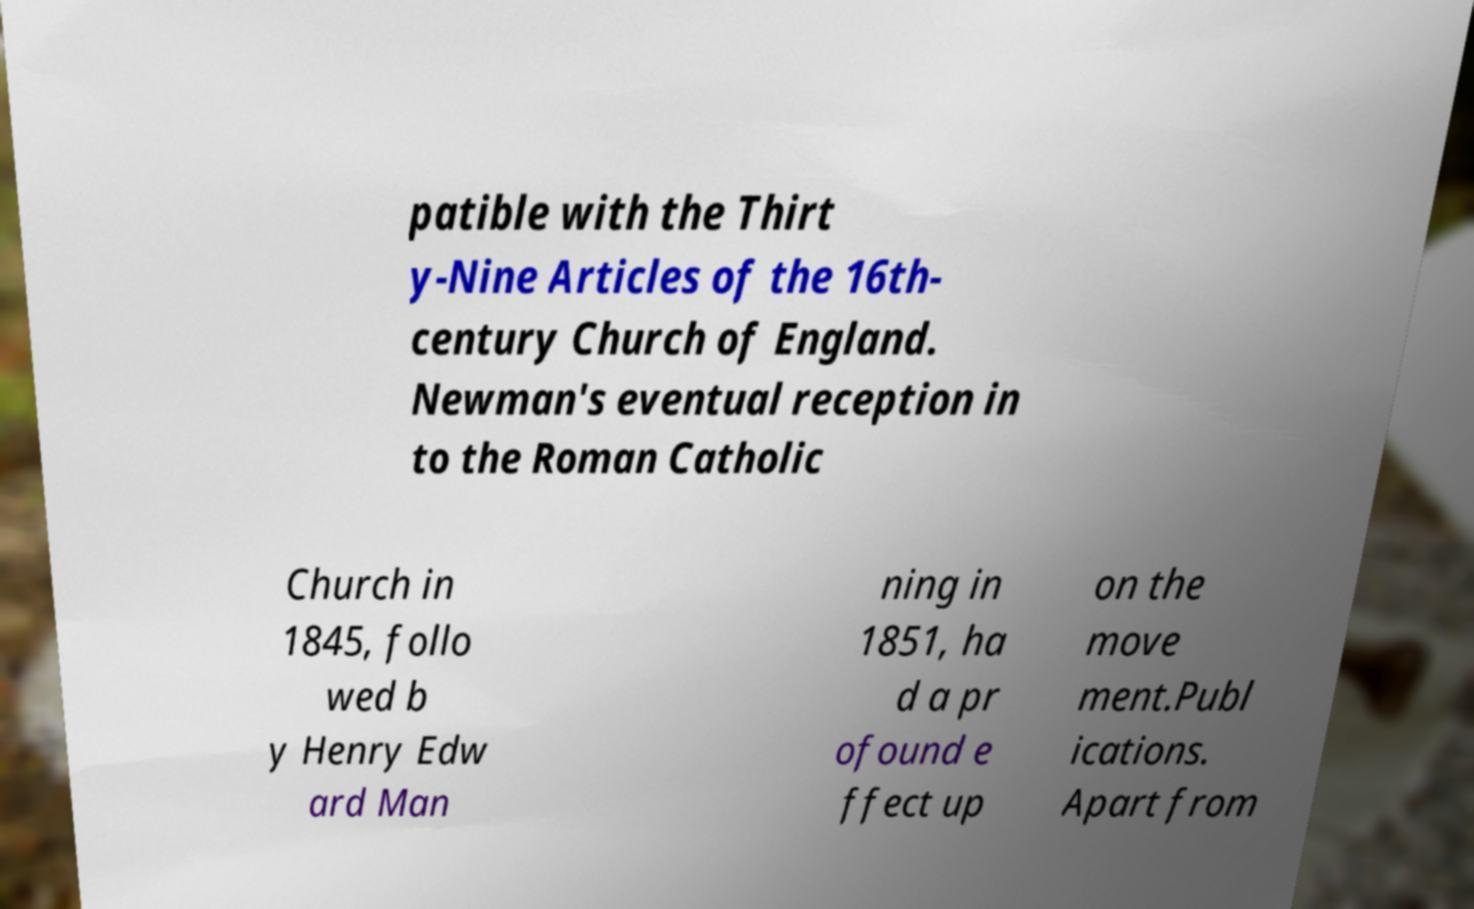Please identify and transcribe the text found in this image. patible with the Thirt y-Nine Articles of the 16th- century Church of England. Newman's eventual reception in to the Roman Catholic Church in 1845, follo wed b y Henry Edw ard Man ning in 1851, ha d a pr ofound e ffect up on the move ment.Publ ications. Apart from 